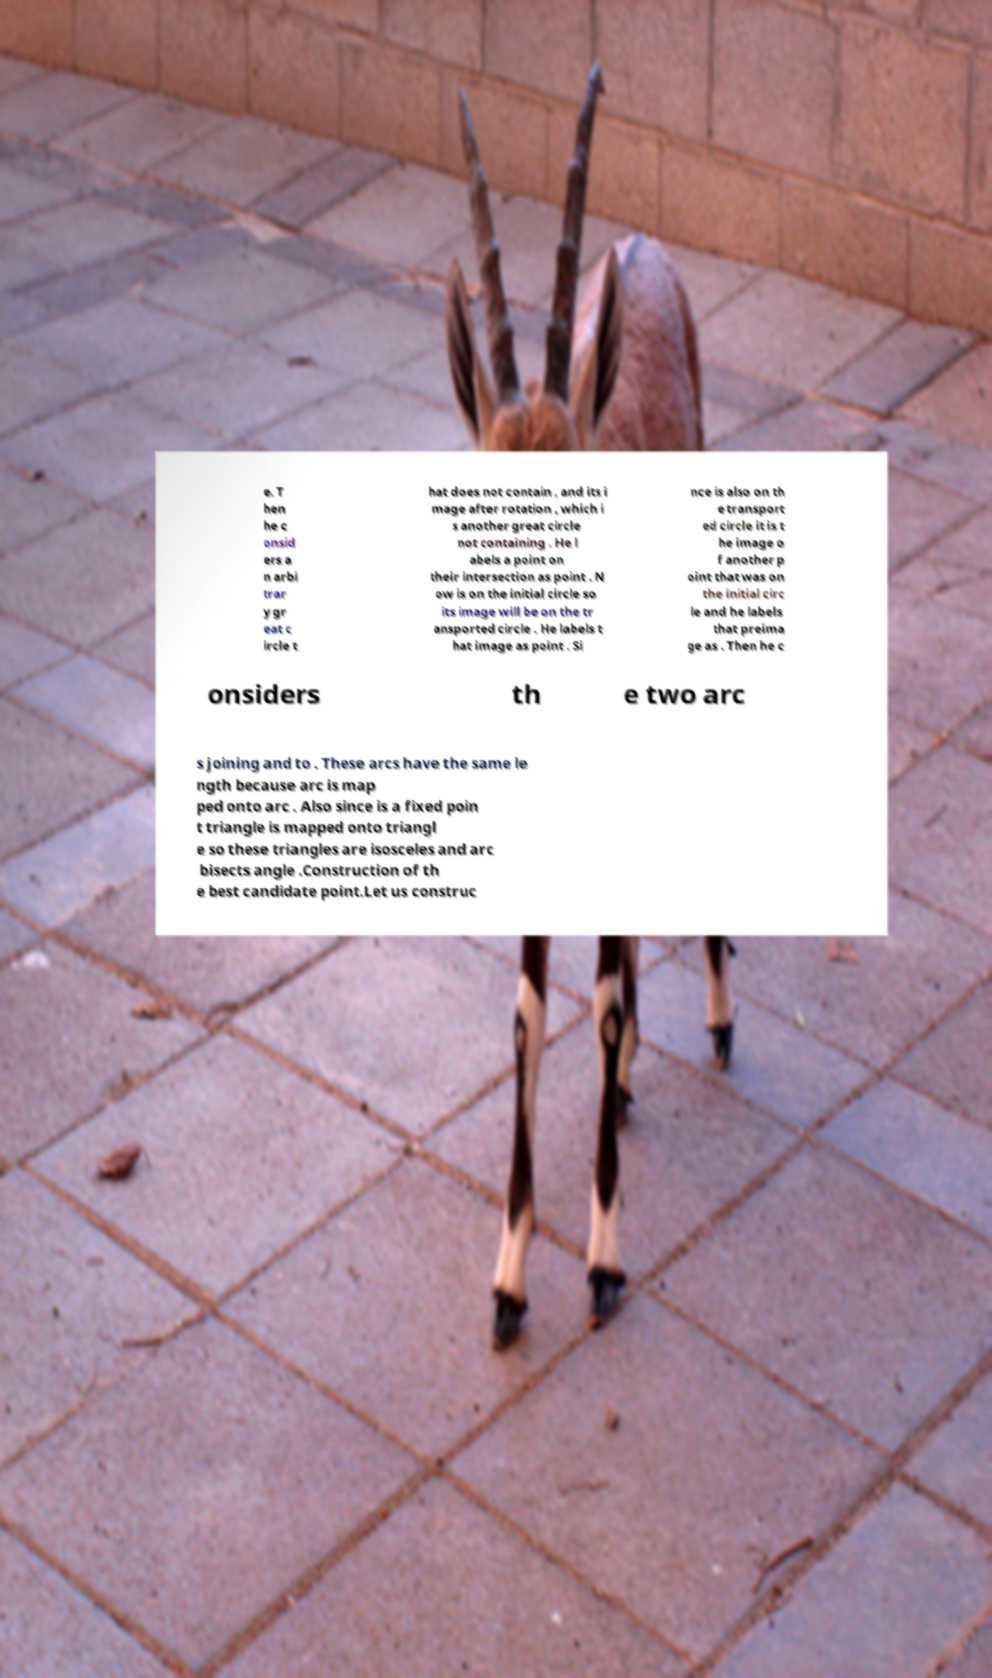Could you assist in decoding the text presented in this image and type it out clearly? e. T hen he c onsid ers a n arbi trar y gr eat c ircle t hat does not contain , and its i mage after rotation , which i s another great circle not containing . He l abels a point on their intersection as point . N ow is on the initial circle so its image will be on the tr ansported circle . He labels t hat image as point . Si nce is also on th e transport ed circle it is t he image o f another p oint that was on the initial circ le and he labels that preima ge as . Then he c onsiders th e two arc s joining and to . These arcs have the same le ngth because arc is map ped onto arc . Also since is a fixed poin t triangle is mapped onto triangl e so these triangles are isosceles and arc bisects angle .Construction of th e best candidate point.Let us construc 